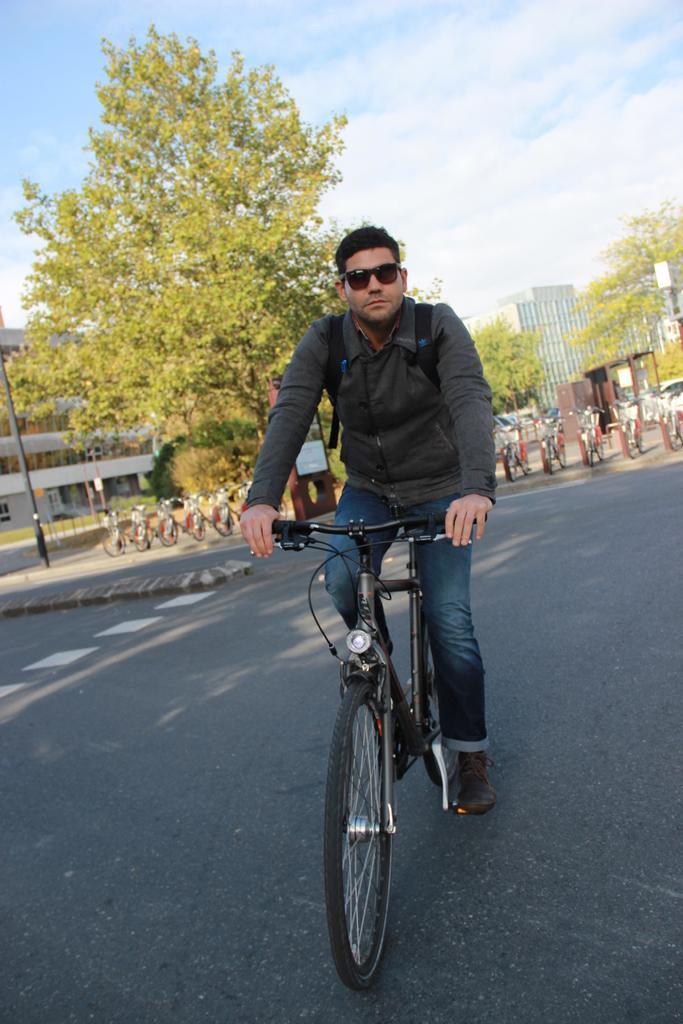How would you summarize this image in a sentence or two? In this image I can see a person riding the bicycle. He is wearing the jacket and goggles. To the back of him there are many bicycles. In the back there are trees,building and the sky. 